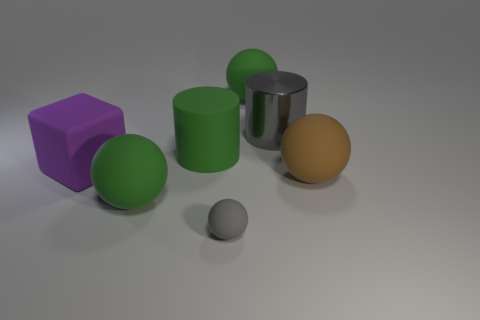What shape is the large rubber object that is both in front of the gray cylinder and behind the large cube?
Offer a very short reply. Cylinder. How many small rubber objects have the same shape as the large metallic object?
Your answer should be very brief. 0. The gray object that is the same material as the purple thing is what size?
Give a very brief answer. Small. How many blocks are the same size as the shiny cylinder?
Provide a succinct answer. 1. What size is the other thing that is the same color as the small rubber thing?
Your answer should be very brief. Large. What is the color of the big cylinder on the right side of the green object to the right of the big green cylinder?
Your answer should be very brief. Gray. Are there any objects that have the same color as the big metal cylinder?
Ensure brevity in your answer.  Yes. What is the color of the shiny thing that is the same size as the purple rubber object?
Make the answer very short. Gray. Do the big ball that is behind the purple object and the tiny thing have the same material?
Offer a terse response. Yes. Is there a big green sphere in front of the green sphere that is behind the large ball in front of the brown object?
Provide a succinct answer. Yes. 